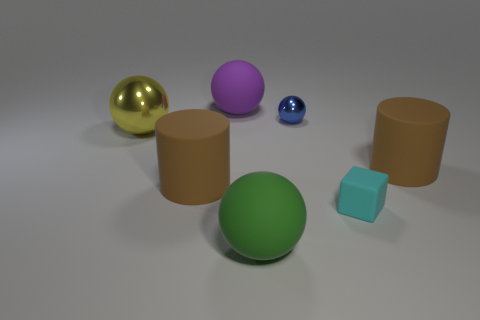Is there anything else that has the same shape as the cyan thing?
Ensure brevity in your answer.  No. How many objects are either big green rubber spheres or cyan objects?
Offer a very short reply. 2. There is a large brown object to the right of the tiny cyan matte cube; does it have the same shape as the large brown matte object that is on the left side of the purple rubber ball?
Make the answer very short. Yes. How many large things are right of the yellow shiny ball and on the left side of the cyan cube?
Give a very brief answer. 3. What number of other objects are there of the same size as the green thing?
Provide a succinct answer. 4. The thing that is behind the large metallic sphere and right of the green rubber object is made of what material?
Offer a very short reply. Metal. The blue metal thing that is the same shape as the large purple thing is what size?
Make the answer very short. Small. What is the shape of the matte object that is both on the left side of the big green matte object and in front of the tiny sphere?
Make the answer very short. Cylinder. There is a yellow sphere; is it the same size as the cylinder on the right side of the green object?
Offer a very short reply. Yes. What is the color of the other metal thing that is the same shape as the small blue thing?
Ensure brevity in your answer.  Yellow. 